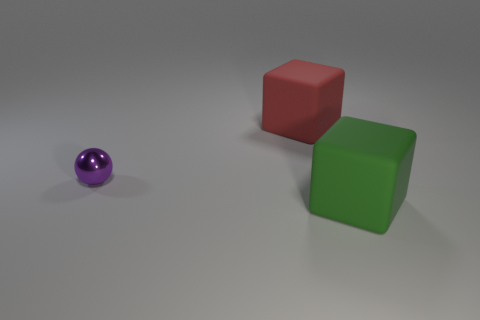What color is the object that is behind the green rubber object and on the right side of the small purple ball?
Your answer should be very brief. Red. Are there any other things that have the same color as the sphere?
Offer a terse response. No. What shape is the small metallic thing that is on the left side of the rubber thing that is to the right of the matte cube behind the tiny purple metallic object?
Provide a short and direct response. Sphere. There is a matte object in front of the big red block; is it the same size as the object on the left side of the large red object?
Provide a succinct answer. No. What number of other big objects are made of the same material as the big green object?
Offer a terse response. 1. What number of small objects are on the right side of the large block behind the big green thing that is to the right of the small purple metallic thing?
Make the answer very short. 0. Is the shape of the green object the same as the purple object?
Provide a succinct answer. No. Are there any other small things of the same shape as the red rubber thing?
Keep it short and to the point. No. The red object that is the same size as the green matte thing is what shape?
Offer a very short reply. Cube. What is the material of the object that is left of the big rubber thing that is behind the rubber thing that is right of the red rubber cube?
Your answer should be compact. Metal. 